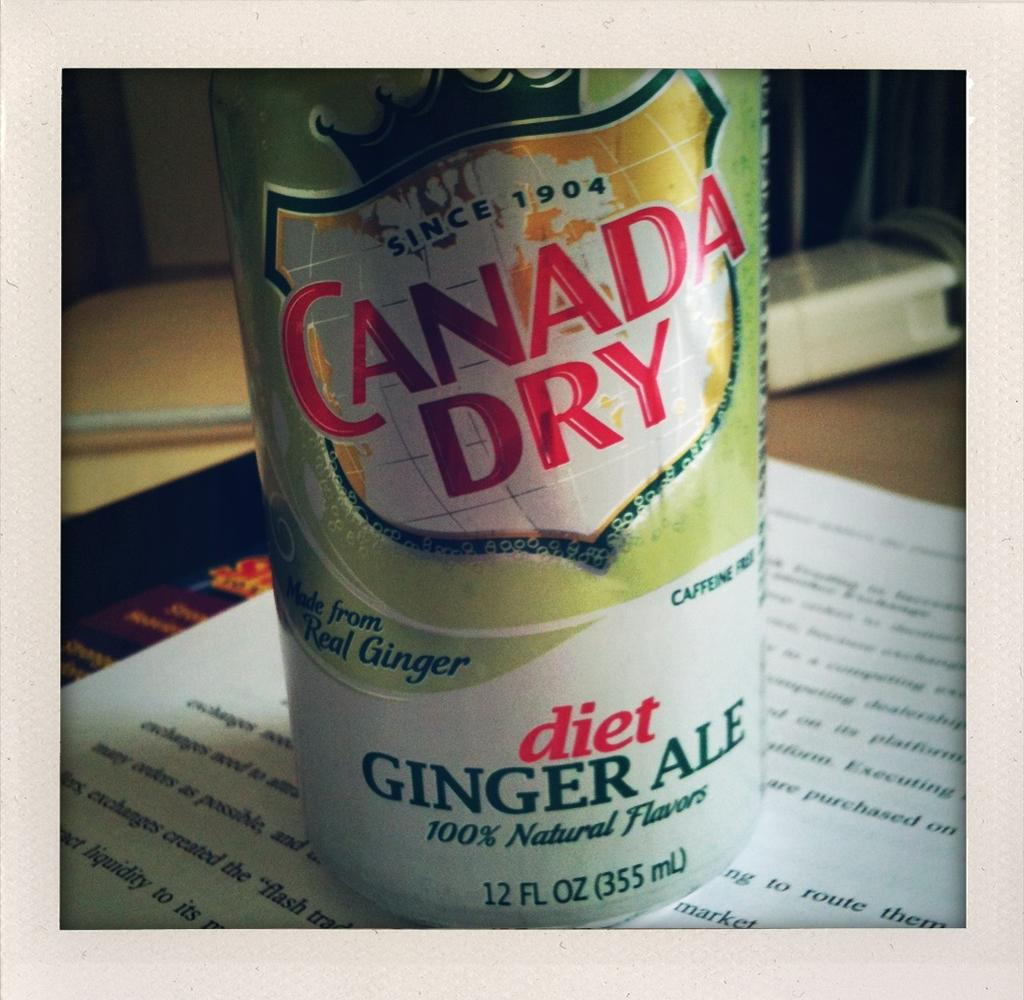<image>
Summarize the visual content of the image. Canady Dry ginger ale can on top of a book. 